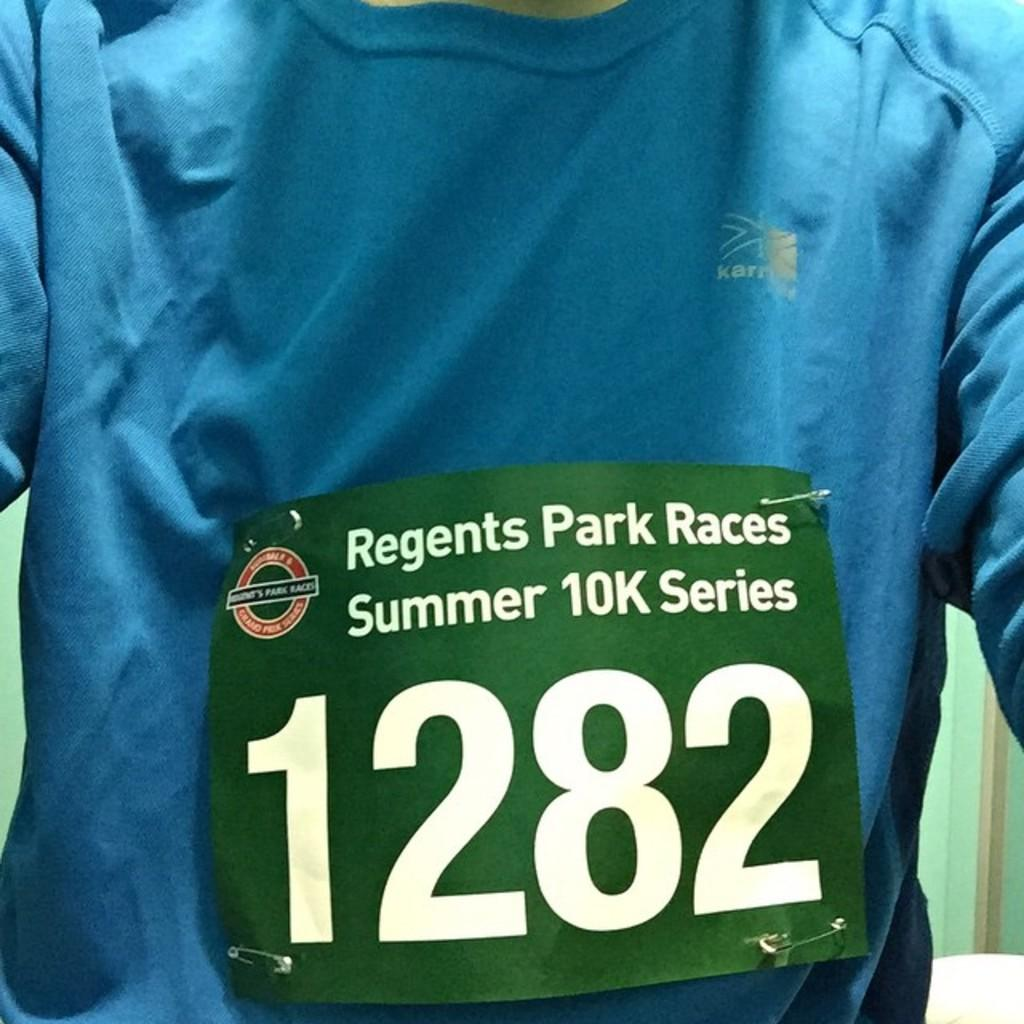<image>
Describe the image concisely. Person wearing a green sign that says 1282 on it. 